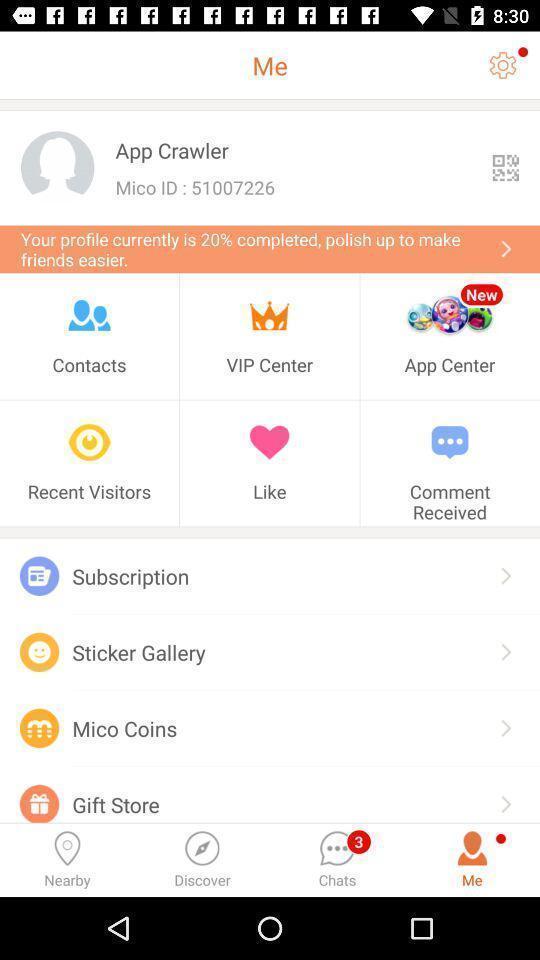Provide a detailed account of this screenshot. Page displays profile various options in app. 